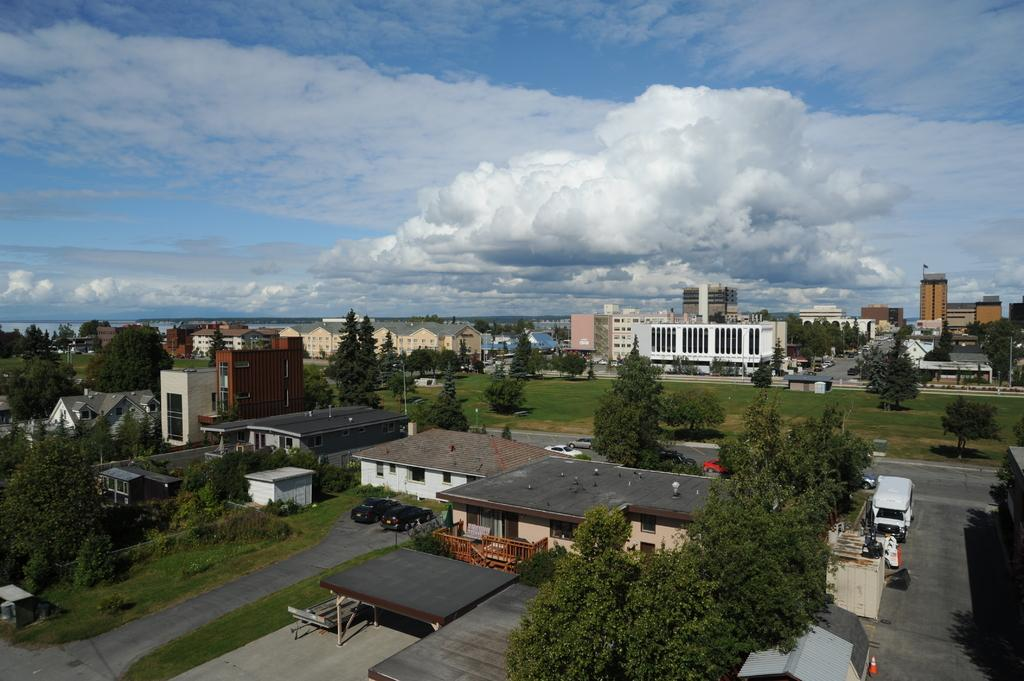What is located in the center of the image? There are buildings in the center of the image. What type of vegetation can be seen in the image? There are trees in the image. What is visible in the background of the image? Clouds and the sky are visible in the background of the image. What type of transportation can be seen in the image? There are vehicles on the road in the image. Can you see the bear's wrist in the image? There is no bear present in the image, so it is not possible to see its wrist. 